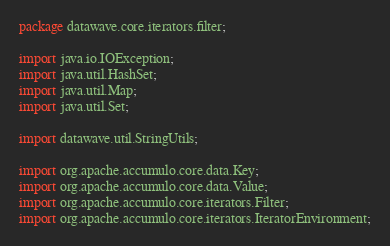<code> <loc_0><loc_0><loc_500><loc_500><_Java_>package datawave.core.iterators.filter;

import java.io.IOException;
import java.util.HashSet;
import java.util.Map;
import java.util.Set;

import datawave.util.StringUtils;

import org.apache.accumulo.core.data.Key;
import org.apache.accumulo.core.data.Value;
import org.apache.accumulo.core.iterators.Filter;
import org.apache.accumulo.core.iterators.IteratorEnvironment;</code> 